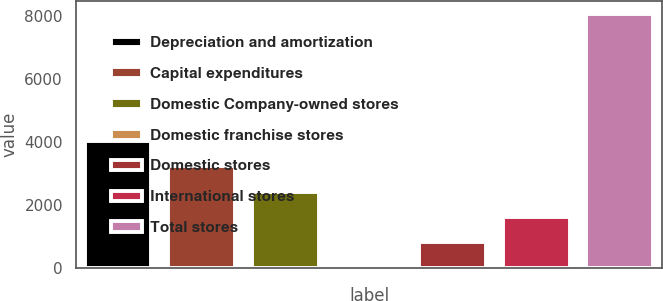<chart> <loc_0><loc_0><loc_500><loc_500><bar_chart><fcel>Depreciation and amortization<fcel>Capital expenditures<fcel>Domestic Company-owned stores<fcel>Domestic franchise stores<fcel>Domestic stores<fcel>International stores<fcel>Total stores<nl><fcel>4041.8<fcel>3234.36<fcel>2426.92<fcel>4.6<fcel>812.04<fcel>1619.48<fcel>8079<nl></chart> 